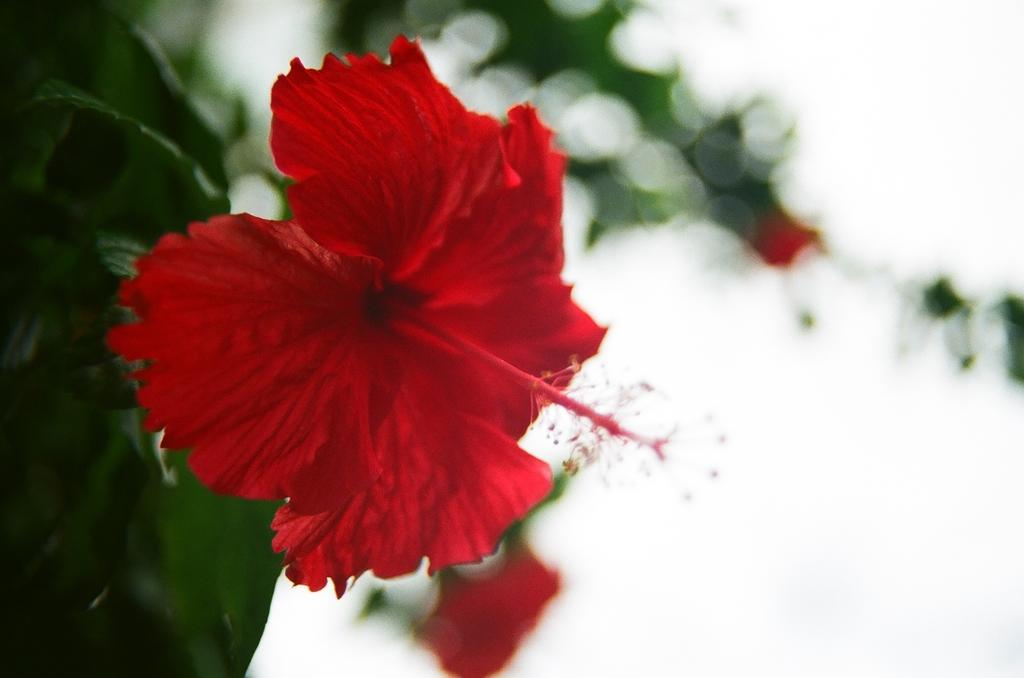What is the main subject in the foreground of the image? There is a red color flower in the foreground of the image. Is the flower part of a larger plant? Yes, the flower is attached to a plant. What can be seen in the background of the image? The sky is visible in the background of the image. What type of bell can be heard ringing in the image? There is no bell present in the image, and therefore no sound can be heard. 